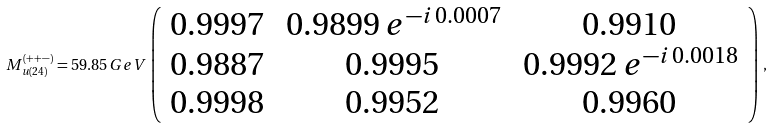<formula> <loc_0><loc_0><loc_500><loc_500>M _ { u ( 2 4 ) } ^ { ( + + - ) } = 5 9 . 8 5 \, G e V \, \left ( \begin{array} { c c c } 0 . 9 9 9 7 & \, 0 . 9 8 9 9 \, e ^ { - i \, 0 . 0 0 0 7 } & 0 . 9 9 1 0 \\ 0 . 9 8 8 7 & 0 . 9 9 9 5 & \, 0 . 9 9 9 2 \, e ^ { - i \, 0 . 0 0 1 8 } \\ 0 . 9 9 9 8 & 0 . 9 9 5 2 & 0 . 9 9 6 0 \end{array} \right ) \, ,</formula> 